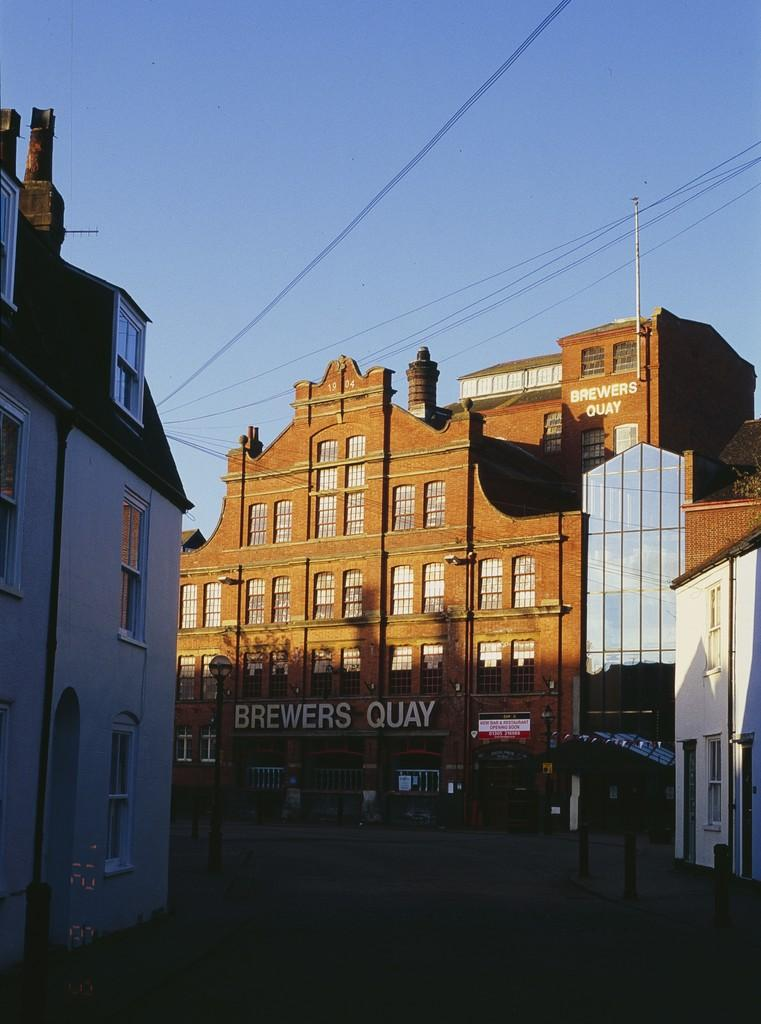What is the main feature of the image? There is a road in the image. What can be seen on either side of the road? There are poles and buildings on either side of the road. What is visible in the background of the image? The sky is visible in the image. How many bulbs are hanging from the poles in the image? There are no bulbs present in the image; only poles and buildings can be seen on either side of the road. 